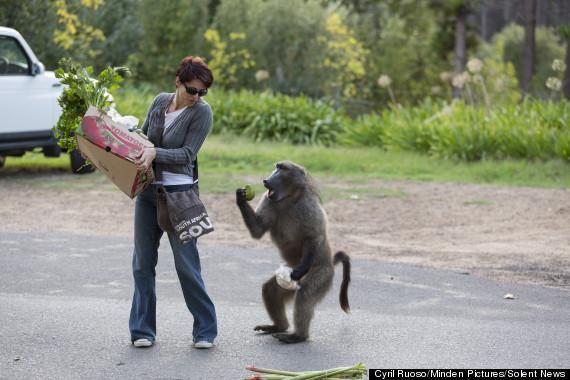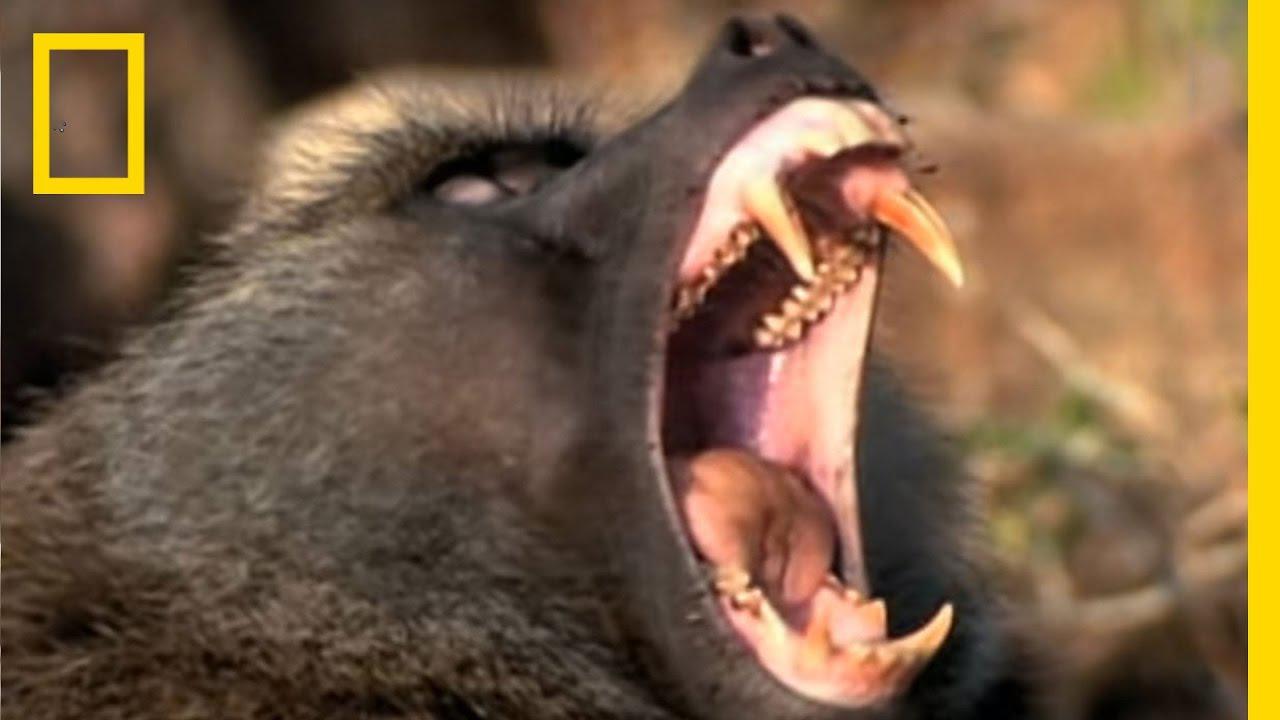The first image is the image on the left, the second image is the image on the right. Evaluate the accuracy of this statement regarding the images: "The left image contains a woman carrying groceries.". Is it true? Answer yes or no. Yes. The first image is the image on the left, the second image is the image on the right. Considering the images on both sides, is "There are monkeys on top of a vehicle's roof in at least one of the images." valid? Answer yes or no. No. 